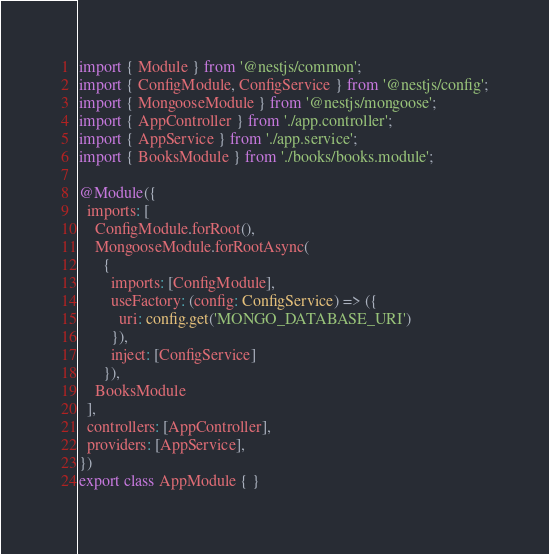Convert code to text. <code><loc_0><loc_0><loc_500><loc_500><_TypeScript_>import { Module } from '@nestjs/common';
import { ConfigModule, ConfigService } from '@nestjs/config';
import { MongooseModule } from '@nestjs/mongoose';
import { AppController } from './app.controller';
import { AppService } from './app.service';
import { BooksModule } from './books/books.module';

@Module({
  imports: [
    ConfigModule.forRoot(),
    MongooseModule.forRootAsync(
      {
        imports: [ConfigModule],
        useFactory: (config: ConfigService) => ({
          uri: config.get('MONGO_DATABASE_URI')
        }),
        inject: [ConfigService]
      }),
    BooksModule
  ],
  controllers: [AppController],
  providers: [AppService],
})
export class AppModule { }
</code> 